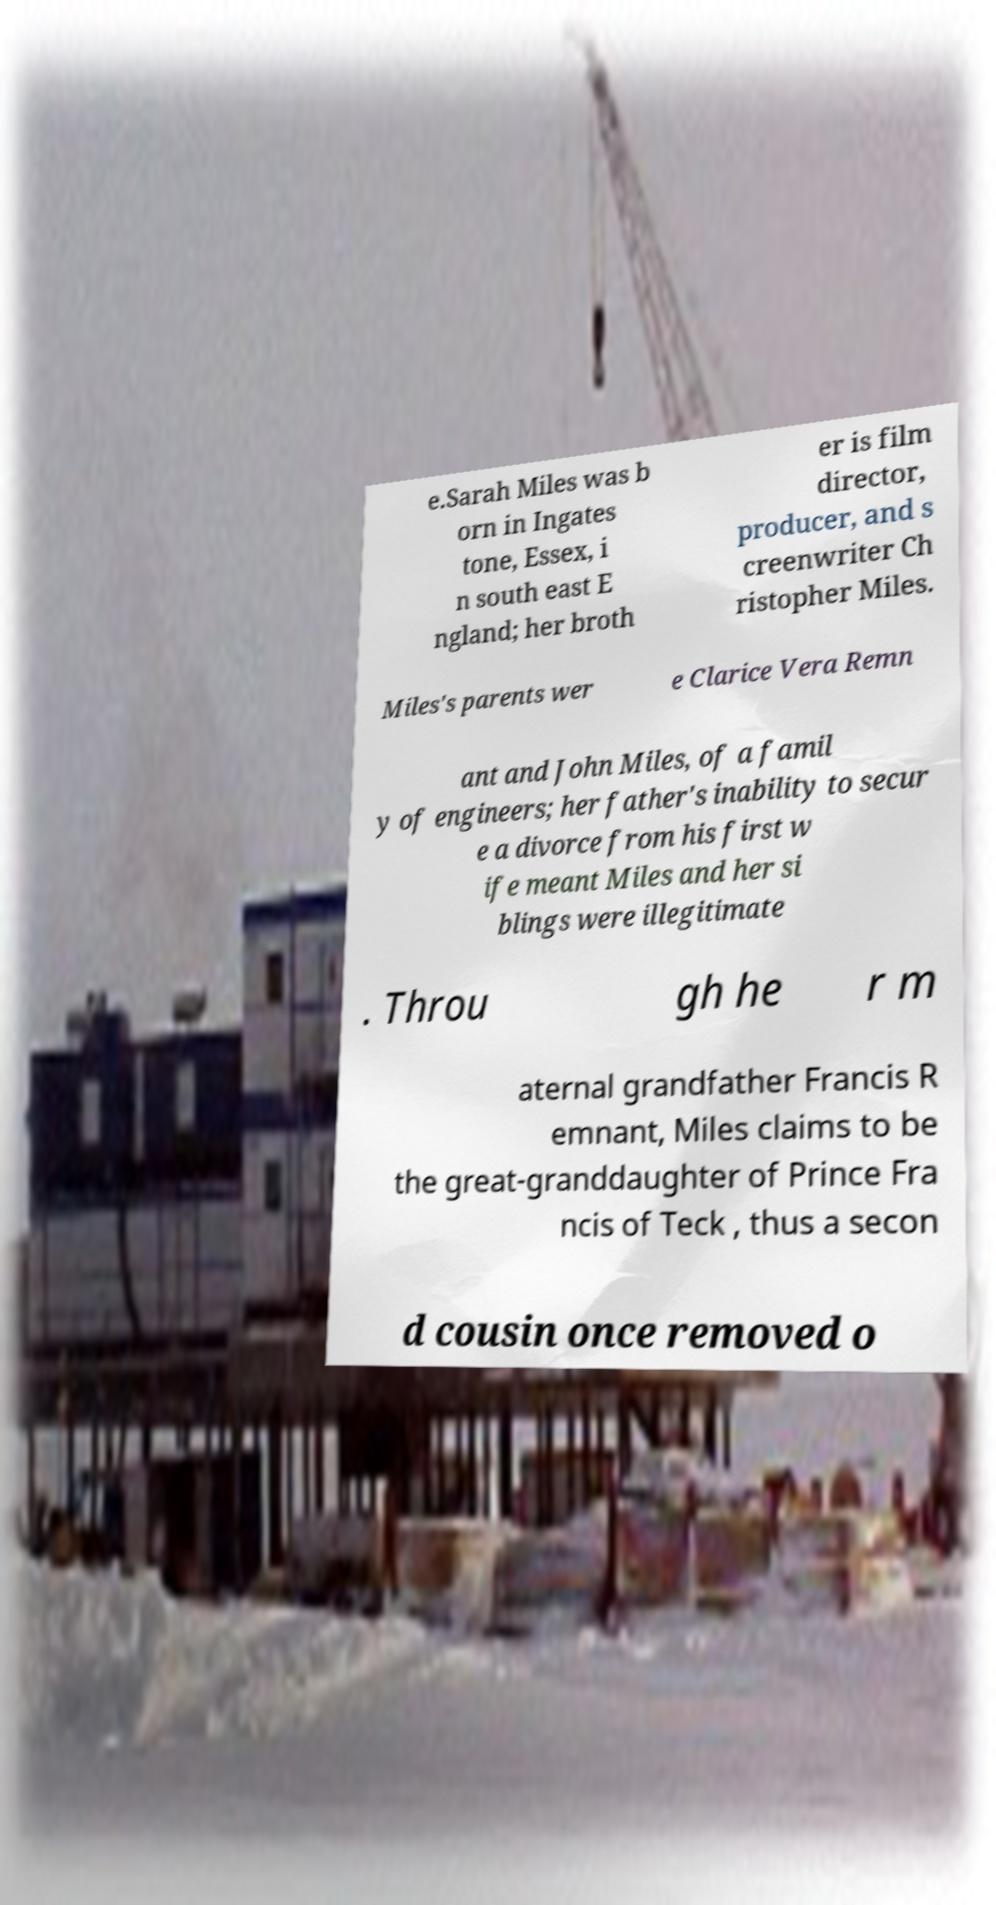I need the written content from this picture converted into text. Can you do that? e.Sarah Miles was b orn in Ingates tone, Essex, i n south east E ngland; her broth er is film director, producer, and s creenwriter Ch ristopher Miles. Miles's parents wer e Clarice Vera Remn ant and John Miles, of a famil y of engineers; her father's inability to secur e a divorce from his first w ife meant Miles and her si blings were illegitimate . Throu gh he r m aternal grandfather Francis R emnant, Miles claims to be the great-granddaughter of Prince Fra ncis of Teck , thus a secon d cousin once removed o 